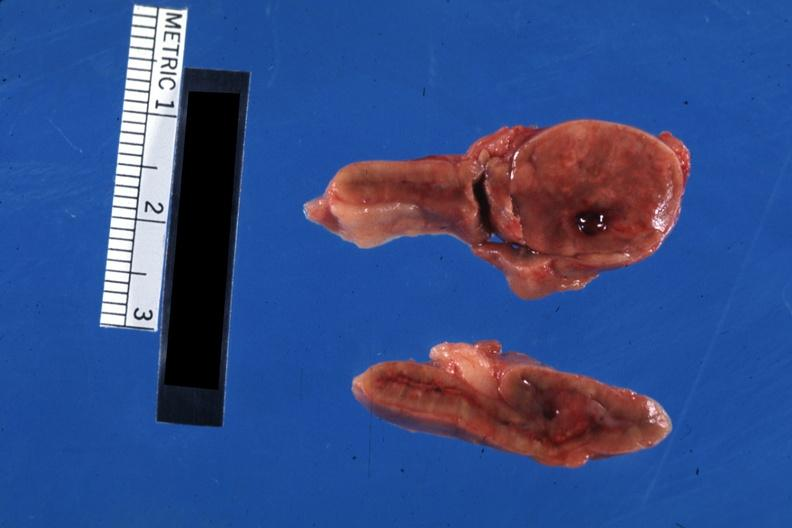s vessel present?
Answer the question using a single word or phrase. No 